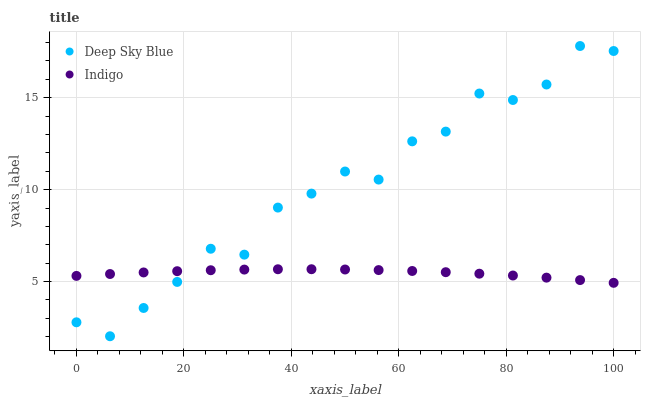Does Indigo have the minimum area under the curve?
Answer yes or no. Yes. Does Deep Sky Blue have the maximum area under the curve?
Answer yes or no. Yes. Does Deep Sky Blue have the minimum area under the curve?
Answer yes or no. No. Is Indigo the smoothest?
Answer yes or no. Yes. Is Deep Sky Blue the roughest?
Answer yes or no. Yes. Is Deep Sky Blue the smoothest?
Answer yes or no. No. Does Deep Sky Blue have the lowest value?
Answer yes or no. Yes. Does Deep Sky Blue have the highest value?
Answer yes or no. Yes. Does Deep Sky Blue intersect Indigo?
Answer yes or no. Yes. Is Deep Sky Blue less than Indigo?
Answer yes or no. No. Is Deep Sky Blue greater than Indigo?
Answer yes or no. No. 